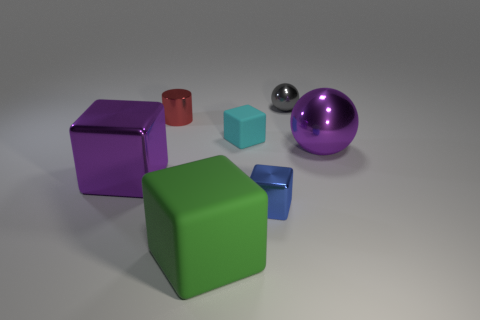Subtract all big green cubes. How many cubes are left? 3 Add 3 large balls. How many objects exist? 10 Subtract all brown blocks. Subtract all red cylinders. How many blocks are left? 4 Subtract all cubes. How many objects are left? 3 Add 2 large purple shiny balls. How many large purple shiny balls are left? 3 Add 2 small metallic spheres. How many small metallic spheres exist? 3 Subtract 0 gray cubes. How many objects are left? 7 Subtract all small cyan rubber spheres. Subtract all tiny blue objects. How many objects are left? 6 